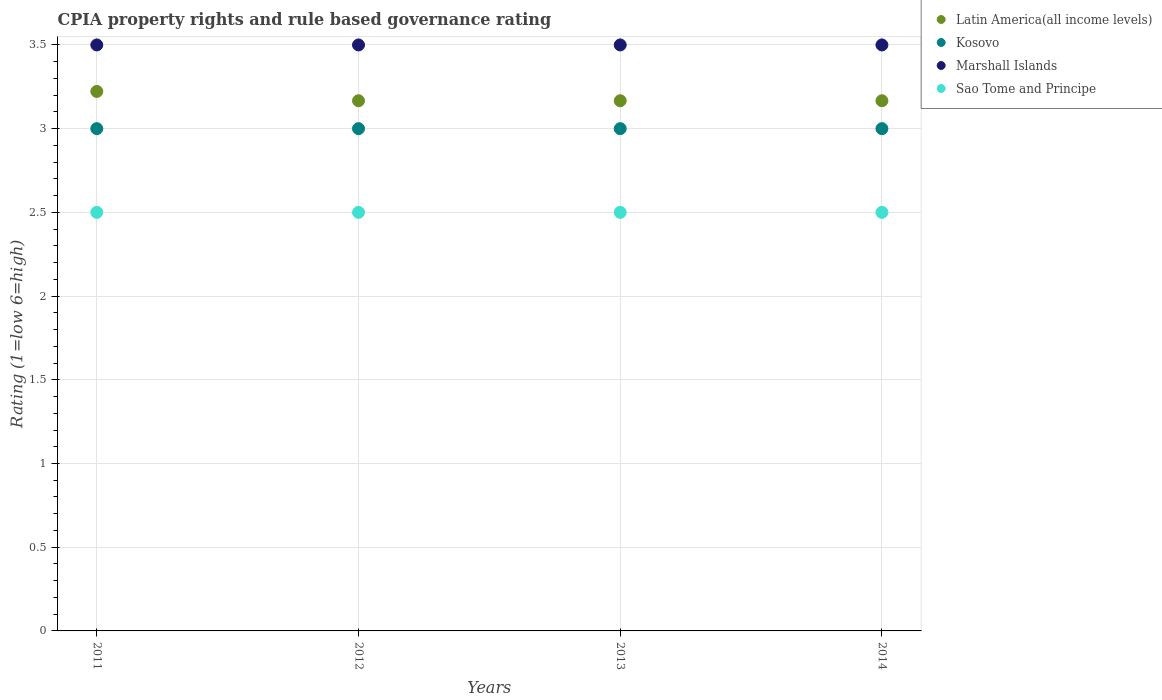In which year was the CPIA rating in Kosovo maximum?
Your response must be concise. 2011. What is the total CPIA rating in Kosovo in the graph?
Your response must be concise. 12. What is the difference between the CPIA rating in Kosovo in 2012 and that in 2013?
Your response must be concise. 0. What is the difference between the CPIA rating in Latin America(all income levels) in 2011 and the CPIA rating in Kosovo in 2014?
Give a very brief answer. 0.22. What is the ratio of the CPIA rating in Latin America(all income levels) in 2011 to that in 2014?
Provide a succinct answer. 1.02. Is the CPIA rating in Kosovo in 2011 less than that in 2014?
Give a very brief answer. No. Is the difference between the CPIA rating in Kosovo in 2012 and 2013 greater than the difference between the CPIA rating in Marshall Islands in 2012 and 2013?
Provide a succinct answer. No. What is the difference between the highest and the second highest CPIA rating in Latin America(all income levels)?
Your answer should be very brief. 0.06. In how many years, is the CPIA rating in Latin America(all income levels) greater than the average CPIA rating in Latin America(all income levels) taken over all years?
Keep it short and to the point. 1. Is it the case that in every year, the sum of the CPIA rating in Kosovo and CPIA rating in Marshall Islands  is greater than the CPIA rating in Latin America(all income levels)?
Provide a succinct answer. Yes. Does the CPIA rating in Marshall Islands monotonically increase over the years?
Your response must be concise. No. Is the CPIA rating in Sao Tome and Principe strictly greater than the CPIA rating in Marshall Islands over the years?
Your response must be concise. No. Is the CPIA rating in Latin America(all income levels) strictly less than the CPIA rating in Marshall Islands over the years?
Give a very brief answer. Yes. How many years are there in the graph?
Keep it short and to the point. 4. Are the values on the major ticks of Y-axis written in scientific E-notation?
Give a very brief answer. No. How are the legend labels stacked?
Your answer should be compact. Vertical. What is the title of the graph?
Make the answer very short. CPIA property rights and rule based governance rating. Does "Grenada" appear as one of the legend labels in the graph?
Make the answer very short. No. What is the label or title of the X-axis?
Keep it short and to the point. Years. What is the label or title of the Y-axis?
Offer a terse response. Rating (1=low 6=high). What is the Rating (1=low 6=high) in Latin America(all income levels) in 2011?
Provide a succinct answer. 3.22. What is the Rating (1=low 6=high) in Marshall Islands in 2011?
Keep it short and to the point. 3.5. What is the Rating (1=low 6=high) of Sao Tome and Principe in 2011?
Your answer should be compact. 2.5. What is the Rating (1=low 6=high) in Latin America(all income levels) in 2012?
Your answer should be very brief. 3.17. What is the Rating (1=low 6=high) of Kosovo in 2012?
Make the answer very short. 3. What is the Rating (1=low 6=high) of Sao Tome and Principe in 2012?
Keep it short and to the point. 2.5. What is the Rating (1=low 6=high) of Latin America(all income levels) in 2013?
Your response must be concise. 3.17. What is the Rating (1=low 6=high) in Marshall Islands in 2013?
Offer a very short reply. 3.5. What is the Rating (1=low 6=high) in Sao Tome and Principe in 2013?
Your response must be concise. 2.5. What is the Rating (1=low 6=high) in Latin America(all income levels) in 2014?
Keep it short and to the point. 3.17. What is the Rating (1=low 6=high) of Sao Tome and Principe in 2014?
Offer a terse response. 2.5. Across all years, what is the maximum Rating (1=low 6=high) of Latin America(all income levels)?
Give a very brief answer. 3.22. Across all years, what is the maximum Rating (1=low 6=high) in Marshall Islands?
Provide a short and direct response. 3.5. Across all years, what is the maximum Rating (1=low 6=high) of Sao Tome and Principe?
Keep it short and to the point. 2.5. Across all years, what is the minimum Rating (1=low 6=high) of Latin America(all income levels)?
Provide a succinct answer. 3.17. Across all years, what is the minimum Rating (1=low 6=high) in Kosovo?
Offer a terse response. 3. Across all years, what is the minimum Rating (1=low 6=high) in Marshall Islands?
Your answer should be compact. 3.5. What is the total Rating (1=low 6=high) of Latin America(all income levels) in the graph?
Make the answer very short. 12.72. What is the difference between the Rating (1=low 6=high) of Latin America(all income levels) in 2011 and that in 2012?
Your response must be concise. 0.06. What is the difference between the Rating (1=low 6=high) of Marshall Islands in 2011 and that in 2012?
Offer a terse response. 0. What is the difference between the Rating (1=low 6=high) in Sao Tome and Principe in 2011 and that in 2012?
Offer a very short reply. 0. What is the difference between the Rating (1=low 6=high) in Latin America(all income levels) in 2011 and that in 2013?
Ensure brevity in your answer.  0.06. What is the difference between the Rating (1=low 6=high) in Kosovo in 2011 and that in 2013?
Your response must be concise. 0. What is the difference between the Rating (1=low 6=high) in Marshall Islands in 2011 and that in 2013?
Ensure brevity in your answer.  0. What is the difference between the Rating (1=low 6=high) of Latin America(all income levels) in 2011 and that in 2014?
Your response must be concise. 0.06. What is the difference between the Rating (1=low 6=high) in Kosovo in 2011 and that in 2014?
Keep it short and to the point. 0. What is the difference between the Rating (1=low 6=high) in Latin America(all income levels) in 2012 and that in 2013?
Ensure brevity in your answer.  0. What is the difference between the Rating (1=low 6=high) in Kosovo in 2012 and that in 2013?
Make the answer very short. 0. What is the difference between the Rating (1=low 6=high) in Sao Tome and Principe in 2012 and that in 2013?
Your answer should be very brief. 0. What is the difference between the Rating (1=low 6=high) in Kosovo in 2012 and that in 2014?
Your response must be concise. 0. What is the difference between the Rating (1=low 6=high) in Marshall Islands in 2012 and that in 2014?
Ensure brevity in your answer.  0. What is the difference between the Rating (1=low 6=high) of Sao Tome and Principe in 2012 and that in 2014?
Your answer should be very brief. 0. What is the difference between the Rating (1=low 6=high) in Marshall Islands in 2013 and that in 2014?
Give a very brief answer. 0. What is the difference between the Rating (1=low 6=high) of Sao Tome and Principe in 2013 and that in 2014?
Your answer should be very brief. 0. What is the difference between the Rating (1=low 6=high) of Latin America(all income levels) in 2011 and the Rating (1=low 6=high) of Kosovo in 2012?
Your answer should be compact. 0.22. What is the difference between the Rating (1=low 6=high) of Latin America(all income levels) in 2011 and the Rating (1=low 6=high) of Marshall Islands in 2012?
Your response must be concise. -0.28. What is the difference between the Rating (1=low 6=high) of Latin America(all income levels) in 2011 and the Rating (1=low 6=high) of Sao Tome and Principe in 2012?
Your response must be concise. 0.72. What is the difference between the Rating (1=low 6=high) in Kosovo in 2011 and the Rating (1=low 6=high) in Marshall Islands in 2012?
Your response must be concise. -0.5. What is the difference between the Rating (1=low 6=high) in Latin America(all income levels) in 2011 and the Rating (1=low 6=high) in Kosovo in 2013?
Your answer should be compact. 0.22. What is the difference between the Rating (1=low 6=high) in Latin America(all income levels) in 2011 and the Rating (1=low 6=high) in Marshall Islands in 2013?
Make the answer very short. -0.28. What is the difference between the Rating (1=low 6=high) of Latin America(all income levels) in 2011 and the Rating (1=low 6=high) of Sao Tome and Principe in 2013?
Provide a succinct answer. 0.72. What is the difference between the Rating (1=low 6=high) in Kosovo in 2011 and the Rating (1=low 6=high) in Sao Tome and Principe in 2013?
Your response must be concise. 0.5. What is the difference between the Rating (1=low 6=high) of Latin America(all income levels) in 2011 and the Rating (1=low 6=high) of Kosovo in 2014?
Provide a short and direct response. 0.22. What is the difference between the Rating (1=low 6=high) of Latin America(all income levels) in 2011 and the Rating (1=low 6=high) of Marshall Islands in 2014?
Offer a very short reply. -0.28. What is the difference between the Rating (1=low 6=high) in Latin America(all income levels) in 2011 and the Rating (1=low 6=high) in Sao Tome and Principe in 2014?
Your answer should be very brief. 0.72. What is the difference between the Rating (1=low 6=high) of Kosovo in 2011 and the Rating (1=low 6=high) of Sao Tome and Principe in 2014?
Give a very brief answer. 0.5. What is the difference between the Rating (1=low 6=high) of Marshall Islands in 2011 and the Rating (1=low 6=high) of Sao Tome and Principe in 2014?
Your answer should be compact. 1. What is the difference between the Rating (1=low 6=high) in Latin America(all income levels) in 2012 and the Rating (1=low 6=high) in Kosovo in 2013?
Offer a terse response. 0.17. What is the difference between the Rating (1=low 6=high) of Kosovo in 2012 and the Rating (1=low 6=high) of Marshall Islands in 2013?
Ensure brevity in your answer.  -0.5. What is the difference between the Rating (1=low 6=high) in Kosovo in 2012 and the Rating (1=low 6=high) in Sao Tome and Principe in 2013?
Your answer should be very brief. 0.5. What is the difference between the Rating (1=low 6=high) of Latin America(all income levels) in 2012 and the Rating (1=low 6=high) of Kosovo in 2014?
Ensure brevity in your answer.  0.17. What is the difference between the Rating (1=low 6=high) of Latin America(all income levels) in 2012 and the Rating (1=low 6=high) of Marshall Islands in 2014?
Ensure brevity in your answer.  -0.33. What is the difference between the Rating (1=low 6=high) in Latin America(all income levels) in 2012 and the Rating (1=low 6=high) in Sao Tome and Principe in 2014?
Make the answer very short. 0.67. What is the difference between the Rating (1=low 6=high) of Kosovo in 2012 and the Rating (1=low 6=high) of Sao Tome and Principe in 2014?
Offer a terse response. 0.5. What is the difference between the Rating (1=low 6=high) of Latin America(all income levels) in 2013 and the Rating (1=low 6=high) of Kosovo in 2014?
Your answer should be very brief. 0.17. What is the difference between the Rating (1=low 6=high) in Kosovo in 2013 and the Rating (1=low 6=high) in Marshall Islands in 2014?
Your response must be concise. -0.5. What is the average Rating (1=low 6=high) of Latin America(all income levels) per year?
Offer a terse response. 3.18. What is the average Rating (1=low 6=high) of Kosovo per year?
Make the answer very short. 3. In the year 2011, what is the difference between the Rating (1=low 6=high) in Latin America(all income levels) and Rating (1=low 6=high) in Kosovo?
Keep it short and to the point. 0.22. In the year 2011, what is the difference between the Rating (1=low 6=high) of Latin America(all income levels) and Rating (1=low 6=high) of Marshall Islands?
Offer a very short reply. -0.28. In the year 2011, what is the difference between the Rating (1=low 6=high) in Latin America(all income levels) and Rating (1=low 6=high) in Sao Tome and Principe?
Give a very brief answer. 0.72. In the year 2011, what is the difference between the Rating (1=low 6=high) in Kosovo and Rating (1=low 6=high) in Marshall Islands?
Keep it short and to the point. -0.5. In the year 2011, what is the difference between the Rating (1=low 6=high) in Kosovo and Rating (1=low 6=high) in Sao Tome and Principe?
Your answer should be compact. 0.5. In the year 2011, what is the difference between the Rating (1=low 6=high) of Marshall Islands and Rating (1=low 6=high) of Sao Tome and Principe?
Give a very brief answer. 1. In the year 2012, what is the difference between the Rating (1=low 6=high) of Latin America(all income levels) and Rating (1=low 6=high) of Kosovo?
Keep it short and to the point. 0.17. In the year 2012, what is the difference between the Rating (1=low 6=high) in Latin America(all income levels) and Rating (1=low 6=high) in Sao Tome and Principe?
Your response must be concise. 0.67. In the year 2012, what is the difference between the Rating (1=low 6=high) of Kosovo and Rating (1=low 6=high) of Marshall Islands?
Keep it short and to the point. -0.5. In the year 2012, what is the difference between the Rating (1=low 6=high) in Marshall Islands and Rating (1=low 6=high) in Sao Tome and Principe?
Provide a succinct answer. 1. In the year 2013, what is the difference between the Rating (1=low 6=high) in Latin America(all income levels) and Rating (1=low 6=high) in Kosovo?
Provide a short and direct response. 0.17. In the year 2013, what is the difference between the Rating (1=low 6=high) of Latin America(all income levels) and Rating (1=low 6=high) of Sao Tome and Principe?
Provide a short and direct response. 0.67. In the year 2013, what is the difference between the Rating (1=low 6=high) of Kosovo and Rating (1=low 6=high) of Marshall Islands?
Your answer should be very brief. -0.5. In the year 2013, what is the difference between the Rating (1=low 6=high) of Marshall Islands and Rating (1=low 6=high) of Sao Tome and Principe?
Provide a succinct answer. 1. In the year 2014, what is the difference between the Rating (1=low 6=high) in Latin America(all income levels) and Rating (1=low 6=high) in Kosovo?
Offer a terse response. 0.17. In the year 2014, what is the difference between the Rating (1=low 6=high) in Latin America(all income levels) and Rating (1=low 6=high) in Marshall Islands?
Keep it short and to the point. -0.33. In the year 2014, what is the difference between the Rating (1=low 6=high) in Latin America(all income levels) and Rating (1=low 6=high) in Sao Tome and Principe?
Keep it short and to the point. 0.67. In the year 2014, what is the difference between the Rating (1=low 6=high) of Kosovo and Rating (1=low 6=high) of Marshall Islands?
Offer a very short reply. -0.5. What is the ratio of the Rating (1=low 6=high) of Latin America(all income levels) in 2011 to that in 2012?
Provide a succinct answer. 1.02. What is the ratio of the Rating (1=low 6=high) of Kosovo in 2011 to that in 2012?
Your answer should be very brief. 1. What is the ratio of the Rating (1=low 6=high) of Latin America(all income levels) in 2011 to that in 2013?
Ensure brevity in your answer.  1.02. What is the ratio of the Rating (1=low 6=high) in Kosovo in 2011 to that in 2013?
Your answer should be compact. 1. What is the ratio of the Rating (1=low 6=high) in Marshall Islands in 2011 to that in 2013?
Give a very brief answer. 1. What is the ratio of the Rating (1=low 6=high) of Latin America(all income levels) in 2011 to that in 2014?
Make the answer very short. 1.02. What is the ratio of the Rating (1=low 6=high) in Kosovo in 2011 to that in 2014?
Provide a succinct answer. 1. What is the ratio of the Rating (1=low 6=high) in Marshall Islands in 2011 to that in 2014?
Give a very brief answer. 1. What is the ratio of the Rating (1=low 6=high) of Kosovo in 2012 to that in 2013?
Your answer should be compact. 1. What is the ratio of the Rating (1=low 6=high) in Marshall Islands in 2012 to that in 2013?
Offer a terse response. 1. What is the ratio of the Rating (1=low 6=high) of Latin America(all income levels) in 2012 to that in 2014?
Make the answer very short. 1. What is the ratio of the Rating (1=low 6=high) of Kosovo in 2012 to that in 2014?
Ensure brevity in your answer.  1. What is the ratio of the Rating (1=low 6=high) in Latin America(all income levels) in 2013 to that in 2014?
Keep it short and to the point. 1. What is the ratio of the Rating (1=low 6=high) of Kosovo in 2013 to that in 2014?
Give a very brief answer. 1. What is the ratio of the Rating (1=low 6=high) in Sao Tome and Principe in 2013 to that in 2014?
Your answer should be very brief. 1. What is the difference between the highest and the second highest Rating (1=low 6=high) in Latin America(all income levels)?
Your answer should be very brief. 0.06. What is the difference between the highest and the second highest Rating (1=low 6=high) of Sao Tome and Principe?
Keep it short and to the point. 0. What is the difference between the highest and the lowest Rating (1=low 6=high) in Latin America(all income levels)?
Provide a succinct answer. 0.06. What is the difference between the highest and the lowest Rating (1=low 6=high) in Marshall Islands?
Give a very brief answer. 0. 